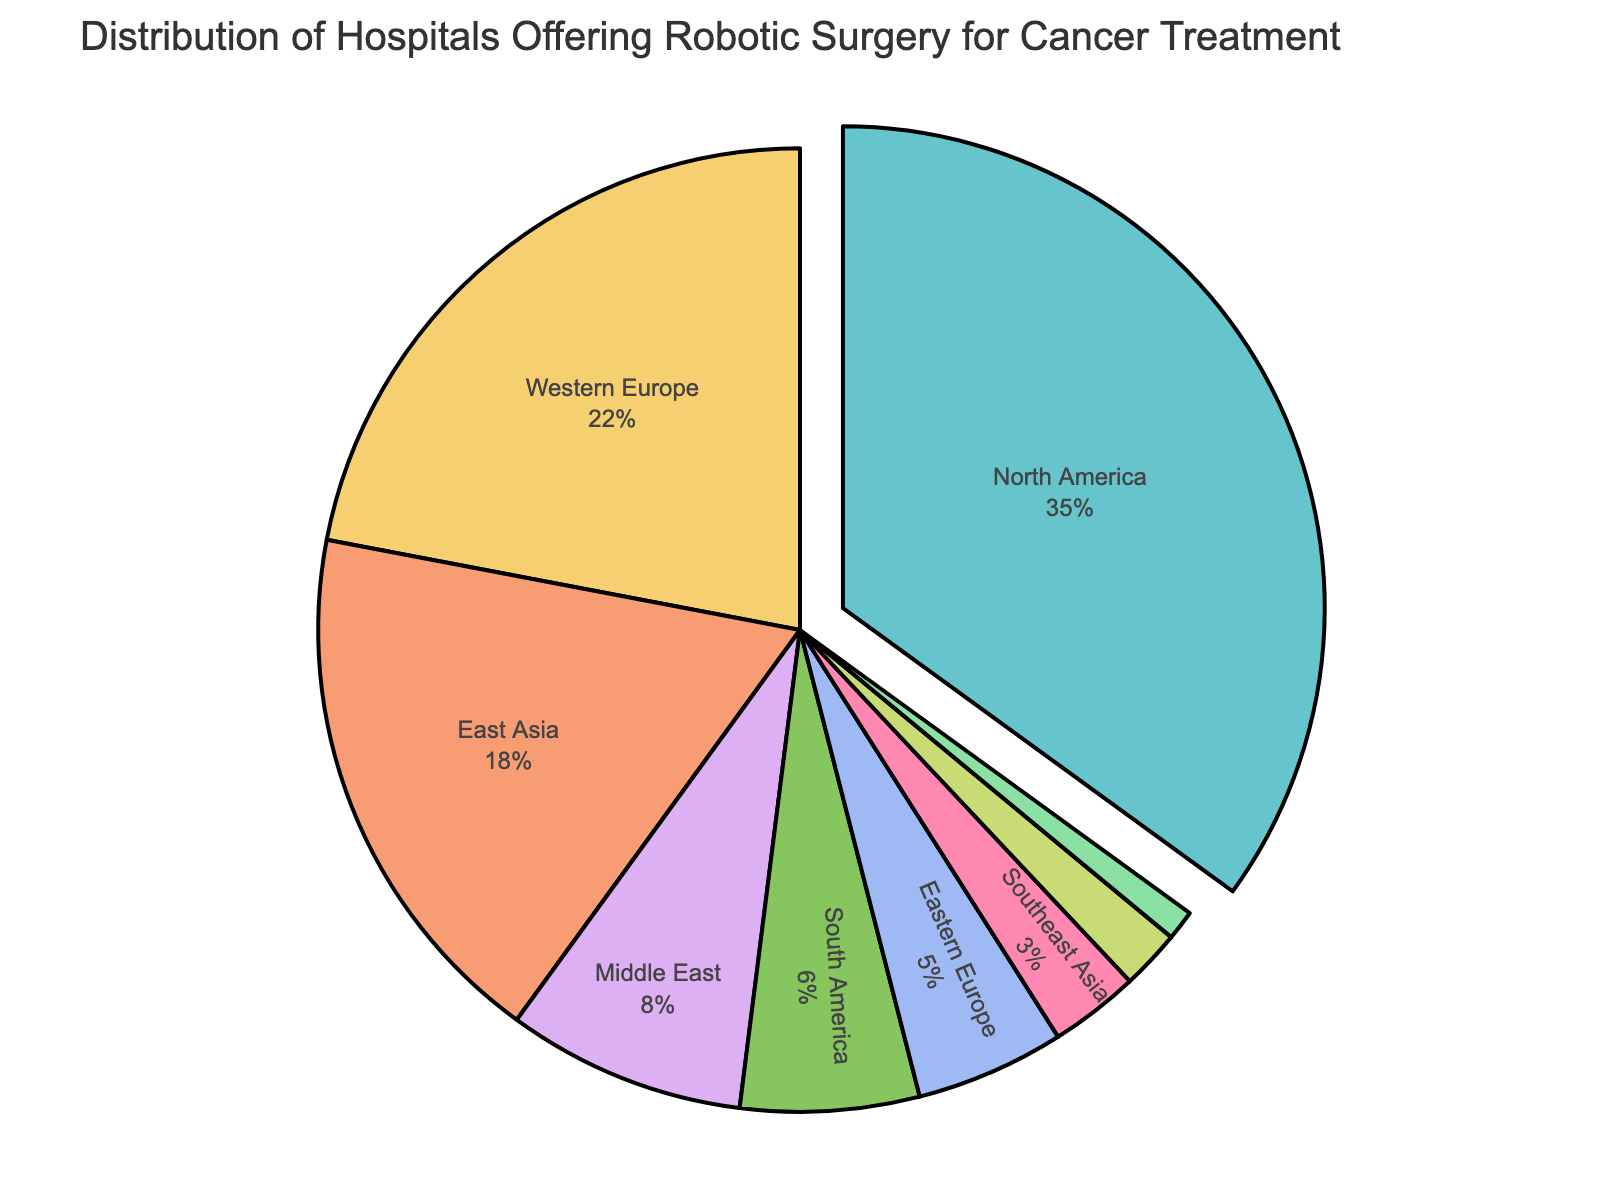What percentage of hospitals offering robotic surgery for cancer treatment are in North America? Look at the North America section of the pie chart, which is labeled with its percentage.
Answer: 35% Which region has the smallest percentage of hospitals offering robotic surgery for cancer treatment? Identify the region with the smallest labeled percentage in the pie chart.
Answer: India How much higher is the percentage of hospitals in North America compared to Western Europe? Subtract the percentage of Western Europe from the percentage of North America (35% - 22%).
Answer: 13% What is the combined percentage of hospitals offering robotic surgery in South America and Eastern Europe? Add the percentages of South America and Eastern Europe (6% + 5%).
Answer: 11% Are there more hospitals offering robotic surgery in East Asia or in Western Europe? Compare the percentages of East Asia and Western Europe; East Asia has 18%, and Western Europe has 22%.
Answer: Western Europe What portion of hospitals offering robotic surgery are in regions other than North America and Western Europe? Subtract the combined percentage of North America and Western Europe from 100% (100% - (35% + 22%)).
Answer: 43% Which region's portion of hospitals offering robotic surgery stands out visually on the pie chart? Identify the region most visually emphasized by the "pull" effect.
Answer: North America What is the percentage difference between East Asia and Southeast Asia? Subtract the percentage of Southeast Asia from East Asia (18% - 3%).
Answer: 15% If you combine the percentage of hospitals in the Middle East and South America, how does it compare to East Asia? Add the percentages of the Middle East and South America (8% + 6%) and compare it to East Asia (14% vs. 18%).
Answer: Less Is the percentage of hospitals offering robotic surgery in Australia and New Zealand greater than or less than the percentage in India? Compare the percentages directly; Australia and New Zealand have 2% while India has 1%.
Answer: Greater 